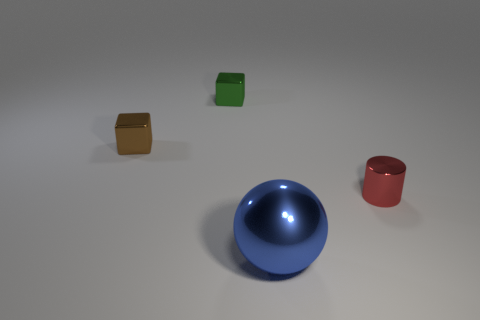Add 1 large green metallic cubes. How many objects exist? 5 Subtract all brown blocks. How many blocks are left? 1 Subtract 1 cubes. How many cubes are left? 1 Subtract all gray balls. Subtract all yellow cylinders. How many balls are left? 1 Subtract all green cylinders. How many blue cubes are left? 0 Subtract all big blue rubber blocks. Subtract all metallic cubes. How many objects are left? 2 Add 1 blue metallic balls. How many blue metallic balls are left? 2 Add 1 green cubes. How many green cubes exist? 2 Subtract 0 red balls. How many objects are left? 4 